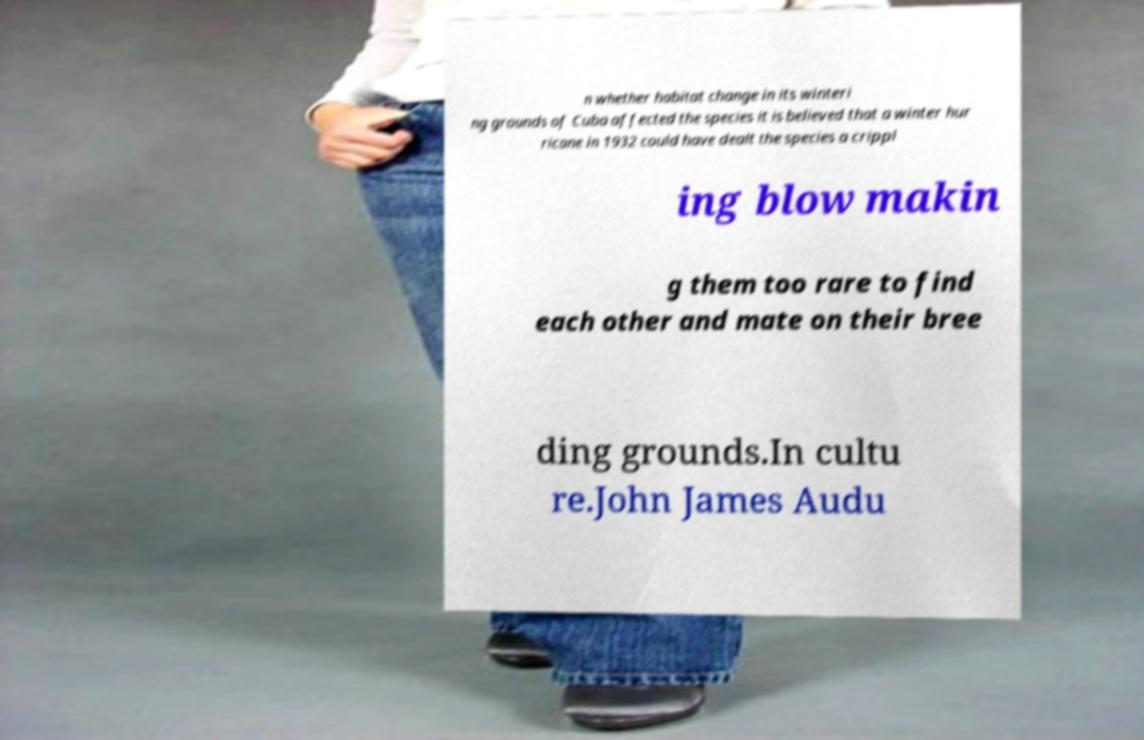Can you accurately transcribe the text from the provided image for me? n whether habitat change in its winteri ng grounds of Cuba affected the species it is believed that a winter hur ricane in 1932 could have dealt the species a crippl ing blow makin g them too rare to find each other and mate on their bree ding grounds.In cultu re.John James Audu 